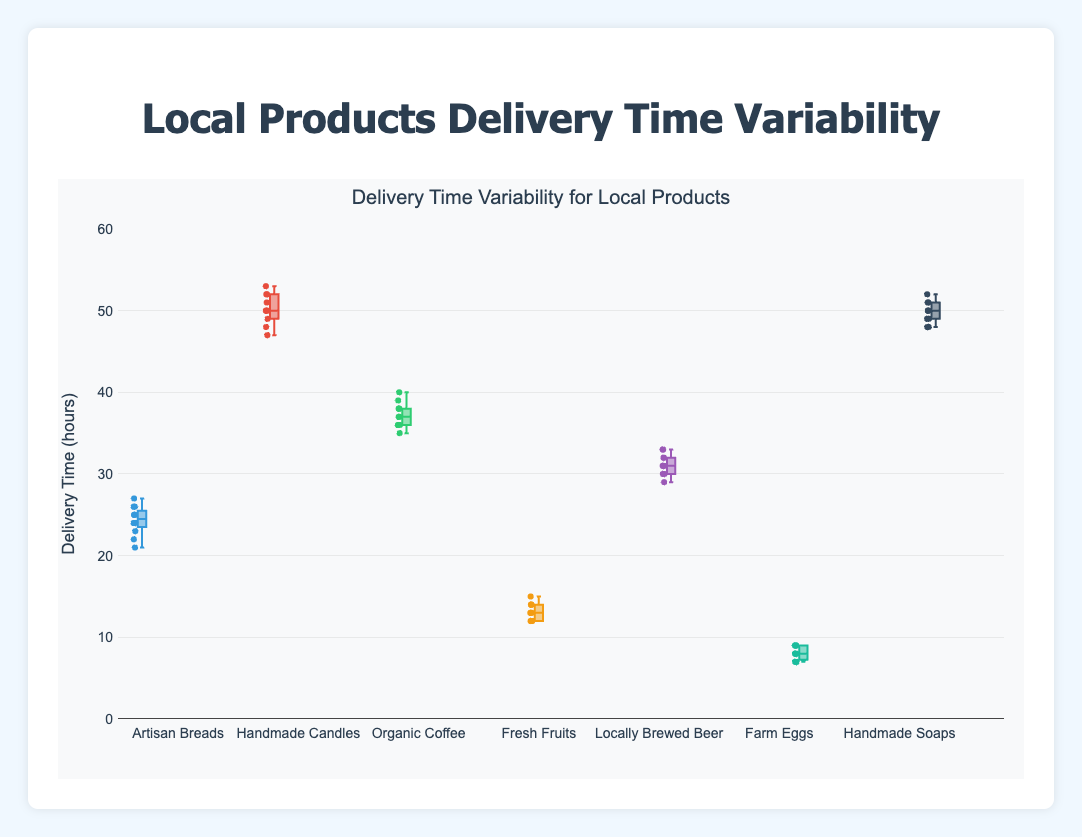What is the title of the figure? The title of the figure is directly displayed above the plot.
Answer: Local Products Delivery Time Variability Which product has the lowest delivery time variability? Looking at the spread of the boxes (the range between the minimum and maximum values including outliers), "Farm Eggs" have the shortest spread.
Answer: Farm Eggs What is the median delivery time for "Artisan Breads"? The median is represented by the line inside the box. For "Artisan Breads", the median delivery time is around 24 hours.
Answer: 24 hours Which product has the highest maximum delivery time? The maximum delivery time is shown by the top whisker or any outliers above the box. "Handmade Candles" has the highest maximum delivery time around 53 hours.
Answer: Handmade Candles How does the delivery time of "Handmade Soaps" compare to "Handmade Candles"? To compare, look at the medians and the spread of both products. The medians are nearly the same (around 50 hours), but "Handmade Candles" has a larger spread and a higher maximum delivery time than "Handmade Soaps".
Answer: Handmade Candles has more variability and a higher maximum What is the interquartile range (IQR) for "Organic Coffee"? The interquartile range is the difference between the 75th percentile and 25th percentile of the data. For "Organic Coffee", 75th percentile is around 38 and 25th percentile is around 36, so IQR is 38-36 = 2.
Answer: 2 hours Which product has the most consistent delivery times, and why? The consistency can be judged by the smallest spread of the box. "Farm Eggs" have the smallest interquartile range and overall range, indicating the most consistent delivery times.
Answer: Farm Eggs What is the approximate range of delivery times for "Fresh Fruits"? The range is the difference between the maximum and minimum values. For "Fresh Fruits", the range is approximately 15-12 = 3 hours.
Answer: 3 hours How many products have a median delivery time greater than 30 hours? Count the number of boxes where the median line is above the 30-hour mark. There are four products with medians above 30 hours: "Handmade Candles", "Organic Coffee", "Locally Brewed Beer", and "Handmade Soaps".
Answer: 4 products 